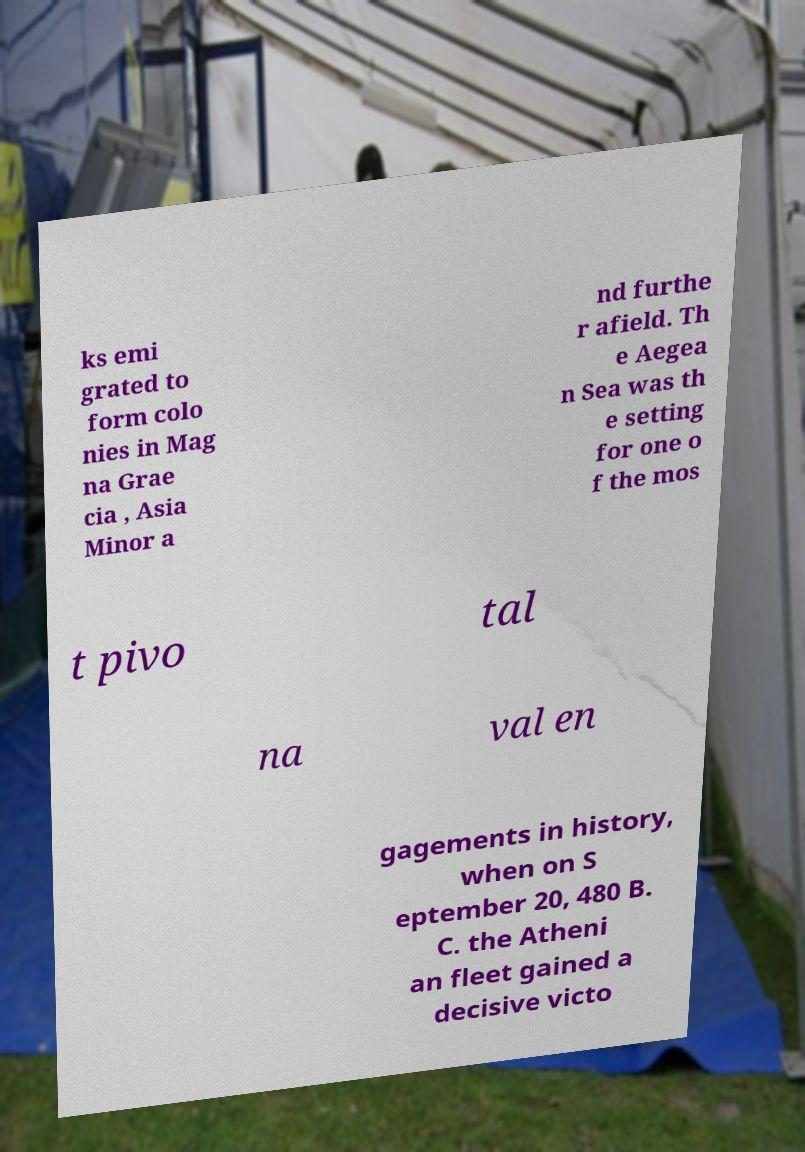Can you accurately transcribe the text from the provided image for me? ks emi grated to form colo nies in Mag na Grae cia , Asia Minor a nd furthe r afield. Th e Aegea n Sea was th e setting for one o f the mos t pivo tal na val en gagements in history, when on S eptember 20, 480 B. C. the Atheni an fleet gained a decisive victo 